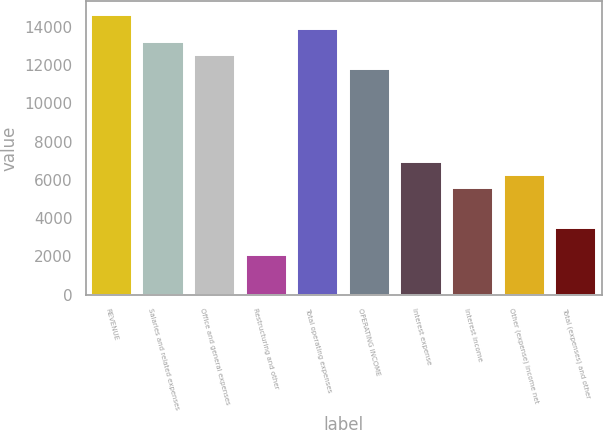Convert chart to OTSL. <chart><loc_0><loc_0><loc_500><loc_500><bar_chart><fcel>REVENUE<fcel>Salaries and related expenses<fcel>Office and general expenses<fcel>Restructuring and other<fcel>Total operating expenses<fcel>OPERATING INCOME<fcel>Interest expense<fcel>Interest income<fcel>Other (expense) income net<fcel>Total (expenses) and other<nl><fcel>14607.8<fcel>13216.6<fcel>12521<fcel>2087.04<fcel>13912.2<fcel>11825.4<fcel>6956.24<fcel>5565.04<fcel>6260.64<fcel>3478.24<nl></chart> 